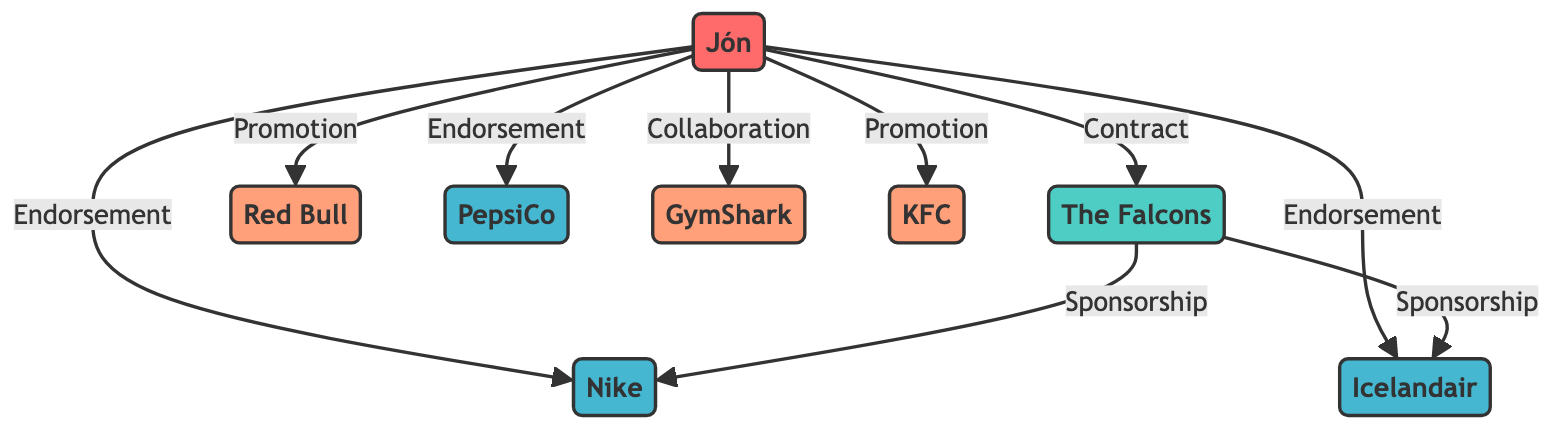What is the total number of nodes in the diagram? To find the total number of nodes, we simply count all unique entities represented in the diagram. There are 8 nodes: Jón, The Falcons, Nike, Red Bull, PepsiCo, GymShark, Icelandair, and KFC.
Answer: 8 What type of relationship does Jón have with Nike? Looking at the edge that connects Jón and Nike, the label indicates that the relationship is an endorsement.
Answer: endorsement Which sponsor is linked to both Jón and The Falcons? Examining the relationships, we see that Nike and Icelandair are connected to The Falcons through sponsorships. However, Icelandair is linked exclusively to Jón by an endorsement. Therefore, the only sponsor linked to both is Nike.
Answer: Nike How many partners are associated with Jón? By analyzing the edges, I can identify that Jón has two partnerships: one with Red Bull (promotion) and one with GymShark (collaboration). Therefore, counting these gives us a total of 2 partners.
Answer: 2 What is the nature of the link between The Falcons and Icelandair? The relationship between The Falcons and Icelandair is described as a sponsorship per the edge connecting them in the diagram.
Answer: sponsorship Which athlete has the most endorsements? By reviewing the endorsements in the diagram, we can see that Jón has three endorsements: Nike, PepsiCo, and Icelandair. Thus, Jón is the athlete with the most endorsements.
Answer: Jón How many sponsorships are connected to The Falcons? There are two edges that indicate sponsorship connections involving The Falcons: one with Nike and another with Icelandair. Therefore, we can conclude there are two sponsorships.
Answer: 2 What type of relationship does Jón have with Red Bull? Examining the edge between Jón and Red Bull, the relationship is labeled as a promotion.
Answer: promotion Which node represents a team in the diagram? The only node labeled as a team in the diagram is The Falcons.
Answer: The Falcons 